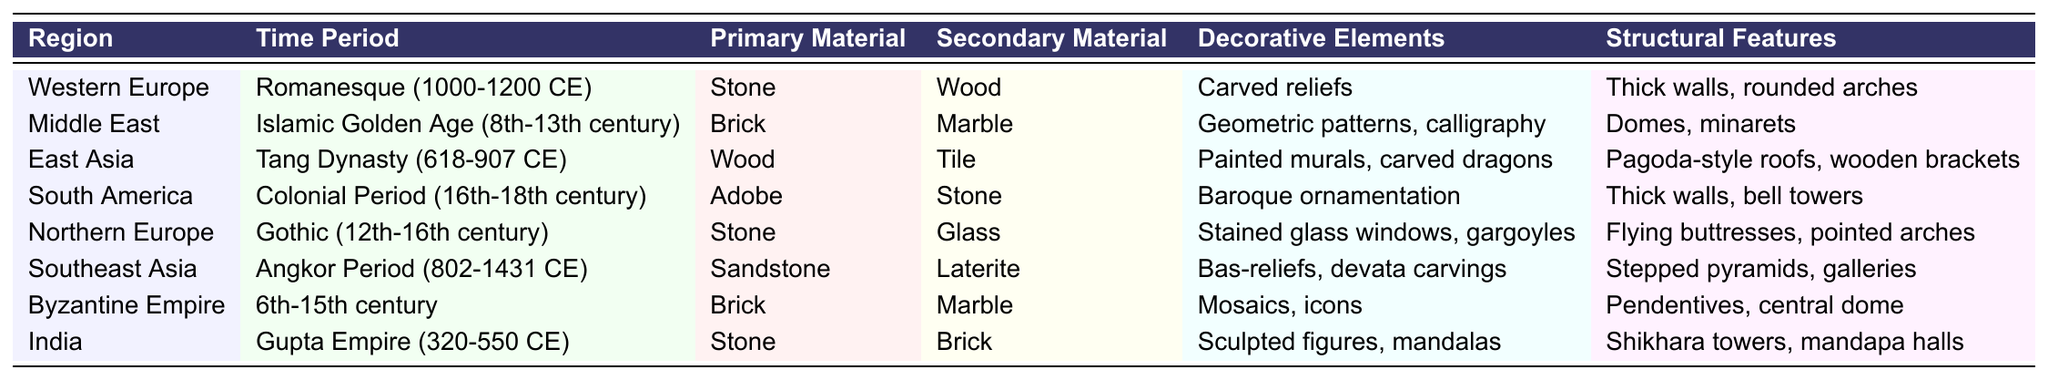What is the primary material used in the Gothic period in Northern Europe? The table indicates that the primary material for the Gothic period (12th-16th century) in Northern Europe is Stone.
Answer: Stone Which region utilized adobe as a primary material during the colonial period? According to the table, the region that used adobe as a primary material during the Colonial Period (16th-18th century) is South America.
Answer: South America What are the decorative elements found in the architecture of the Islamic Golden Age? The table shows that the decorative elements during the Islamic Golden Age (8th-13th century) include geometric patterns and calligraphy.
Answer: Geometric patterns, calligraphy Is marble used as a primary material in any of the listed regions? Referring to the table, marble is not used as a primary material in any region but is listed as a secondary material for the Middle East and Byzantine Empire.
Answer: No Which region shows the use of stained glass windows as a decorative element? The table states that stained glass windows are decorative elements in Northern Europe during the Gothic period (12th-16th century).
Answer: Northern Europe Count the total number of regions listed in the table and state them. The table lists a total of 8 regions: Western Europe, Middle East, East Asia, South America, Northern Europe, Southeast Asia, Byzantine Empire, and India.
Answer: 8 regions What are the structural features associated with the Tang Dynasty architecture? From the table, the structural features for architecture in the Tang Dynasty (618-907 CE) are pagoda-style roofs and wooden brackets.
Answer: Pagoda-style roofs, wooden brackets Which two regions share brick as a primary material, and during what time periods? The table indicates that both the Middle East (Islamic Golden Age) and the Byzantine Empire (6th-15th century) use brick as their primary material.
Answer: Middle East: Islamic Golden Age, Byzantine Empire: 6th-15th century What is the secondary material used alongside sandstone in Southeast Asia during the Angkor Period? According to the table, laterite is the secondary material used alongside sandstone in Southeast Asia during the Angkor Period (802-1431 CE).
Answer: Laterite Which time period features the use of thick walls and rounded arches as structural features? The table indicates that the Romanesque period (1000-1200 CE) features thick walls and rounded arches as structural features.
Answer: Romanesque period 